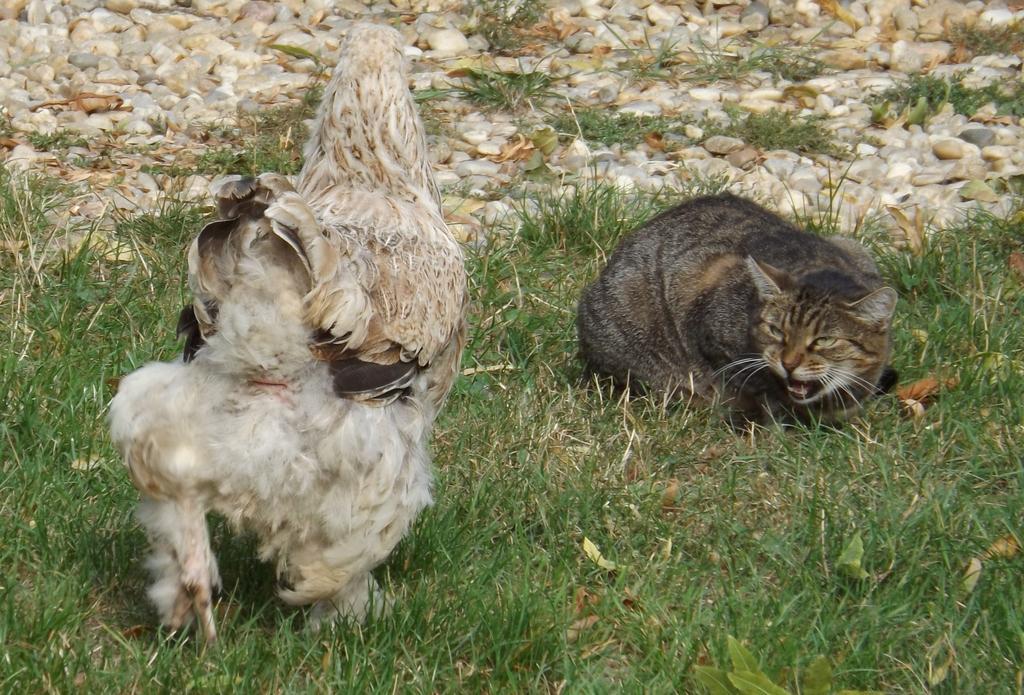Can you describe this image briefly? In this picture I can see a cat and a hen on the ground. I can also see grass and stones. 